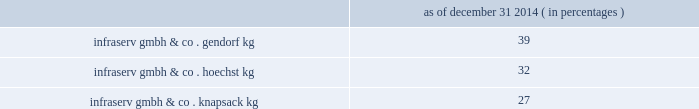Fortron industries llc .
Fortron is a leading global producer of pps , sold under the fortron ae brand , which is used in a wide variety of automotive and other applications , especially those requiring heat and/or chemical resistance .
Fortron's facility is located in wilmington , north carolina .
This venture combines the sales , marketing , distribution , compounding and manufacturing expertise of celanese with the pps polymer technology expertise of kureha america inc .
Cellulose derivatives strategic ventures .
Our cellulose derivatives ventures generally fund their operations using operating cash flow and pay dividends based on each ventures' performance in the preceding year .
In 2014 , 2013 and 2012 , we received cash dividends of $ 115 million , $ 92 million and $ 83 million , respectively .
Although our ownership interest in each of our cellulose derivatives ventures exceeds 20% ( 20 % ) , we account for these investments using the cost method of accounting because we determined that we cannot exercise significant influence over these entities due to local government investment in and influence over these entities , limitations on our involvement in the day-to-day operations and the present inability of the entities to provide timely financial information prepared in accordance with generally accepted accounting principles in the united states of america ( "us gaap" ) .
2022 other equity method investments infraservs .
We hold indirect ownership interests in several german infraserv groups that own and develop industrial parks and provide on-site general and administrative support to tenants .
Our ownership interest in the equity investments in infraserv affiliates are as follows : as of december 31 , 2014 ( in percentages ) .
Research and development our businesses are innovation-oriented and conduct research and development activities to develop new , and optimize existing , production technologies , as well as to develop commercially viable new products and applications .
Research and development expense was $ 86 million , $ 85 million and $ 104 million for the years ended december 31 , 2014 , 2013 and 2012 , respectively .
We consider the amounts spent during each of the last three fiscal years on research and development activities to be sufficient to execute our current strategic initiatives .
Intellectual property we attach importance to protecting our intellectual property , including safeguarding our confidential information and through our patents , trademarks and copyrights , in order to preserve our investment in research and development , manufacturing and marketing .
Patents may cover processes , equipment , products , intermediate products and product uses .
We also seek to register trademarks as a means of protecting the brand names of our company and products .
Patents .
In most industrial countries , patent protection exists for new substances and formulations , as well as for certain unique applications and production processes .
However , we do business in regions of the world where intellectual property protection may be limited and difficult to enforce .
Confidential information .
We maintain stringent information security policies and procedures wherever we do business .
Such information security policies and procedures include data encryption , controls over the disclosure and safekeeping of confidential information and trade secrets , as well as employee awareness training .
Trademarks .
Aoplus ae , aoplus ae2 , aoplus ae3 , ateva ae , avicor ae , britecoat ae , celanese ae , celanex ae , celcon ae , celfx 2122 , celstran ae , celvolit ae , clarifoil ae , duroset ae , ecovae ae , factor ae , fortron ae , gur ae , hostaform ae , impet ae , mowilith ae , nutrinova ae , qorus 2122 , riteflex ae , sunett ae , tcx 2122 , thermx ae , tufcor ae , vantage ae , vantageplus 2122 , vantage ae2 , vectra ae , vinamul ae , vitaldose ae , zenite ae and certain other branded products and services named in this document are registered or reserved trademarks or service marks owned or licensed by celanese .
The foregoing is not intended to be an exhaustive or comprehensive list of all registered or reserved trademarks and service marks owned or licensed by celanese .
Fortron ae is a registered trademark of fortron industries llc. .
What is the growth rate in research and development expenses from 2012 to 2013? 
Computations: ((85 - 104) / 104)
Answer: -0.18269. Fortron industries llc .
Fortron is a leading global producer of pps , sold under the fortron ae brand , which is used in a wide variety of automotive and other applications , especially those requiring heat and/or chemical resistance .
Fortron's facility is located in wilmington , north carolina .
This venture combines the sales , marketing , distribution , compounding and manufacturing expertise of celanese with the pps polymer technology expertise of kureha america inc .
Cellulose derivatives strategic ventures .
Our cellulose derivatives ventures generally fund their operations using operating cash flow and pay dividends based on each ventures' performance in the preceding year .
In 2014 , 2013 and 2012 , we received cash dividends of $ 115 million , $ 92 million and $ 83 million , respectively .
Although our ownership interest in each of our cellulose derivatives ventures exceeds 20% ( 20 % ) , we account for these investments using the cost method of accounting because we determined that we cannot exercise significant influence over these entities due to local government investment in and influence over these entities , limitations on our involvement in the day-to-day operations and the present inability of the entities to provide timely financial information prepared in accordance with generally accepted accounting principles in the united states of america ( "us gaap" ) .
2022 other equity method investments infraservs .
We hold indirect ownership interests in several german infraserv groups that own and develop industrial parks and provide on-site general and administrative support to tenants .
Our ownership interest in the equity investments in infraserv affiliates are as follows : as of december 31 , 2014 ( in percentages ) .
Research and development our businesses are innovation-oriented and conduct research and development activities to develop new , and optimize existing , production technologies , as well as to develop commercially viable new products and applications .
Research and development expense was $ 86 million , $ 85 million and $ 104 million for the years ended december 31 , 2014 , 2013 and 2012 , respectively .
We consider the amounts spent during each of the last three fiscal years on research and development activities to be sufficient to execute our current strategic initiatives .
Intellectual property we attach importance to protecting our intellectual property , including safeguarding our confidential information and through our patents , trademarks and copyrights , in order to preserve our investment in research and development , manufacturing and marketing .
Patents may cover processes , equipment , products , intermediate products and product uses .
We also seek to register trademarks as a means of protecting the brand names of our company and products .
Patents .
In most industrial countries , patent protection exists for new substances and formulations , as well as for certain unique applications and production processes .
However , we do business in regions of the world where intellectual property protection may be limited and difficult to enforce .
Confidential information .
We maintain stringent information security policies and procedures wherever we do business .
Such information security policies and procedures include data encryption , controls over the disclosure and safekeeping of confidential information and trade secrets , as well as employee awareness training .
Trademarks .
Aoplus ae , aoplus ae2 , aoplus ae3 , ateva ae , avicor ae , britecoat ae , celanese ae , celanex ae , celcon ae , celfx 2122 , celstran ae , celvolit ae , clarifoil ae , duroset ae , ecovae ae , factor ae , fortron ae , gur ae , hostaform ae , impet ae , mowilith ae , nutrinova ae , qorus 2122 , riteflex ae , sunett ae , tcx 2122 , thermx ae , tufcor ae , vantage ae , vantageplus 2122 , vantage ae2 , vectra ae , vinamul ae , vitaldose ae , zenite ae and certain other branded products and services named in this document are registered or reserved trademarks or service marks owned or licensed by celanese .
The foregoing is not intended to be an exhaustive or comprehensive list of all registered or reserved trademarks and service marks owned or licensed by celanese .
Fortron ae is a registered trademark of fortron industries llc. .
What was the percentage growth of the cash dividends from 2012 to 2014? 
Rationale: from 2012 to 2014 there was a growth in cash dividends of 39%
Computations: ((115 - 83) / 83)
Answer: 0.38554. 